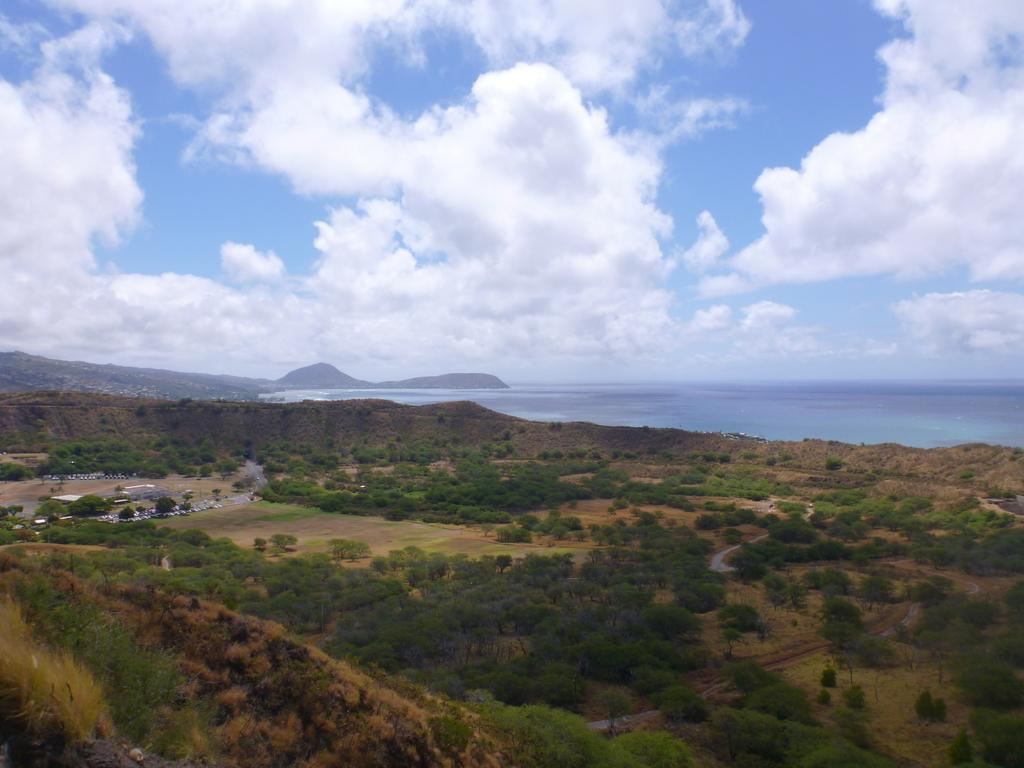What type of vegetation can be seen in the image? There are green color trees in the image. What natural feature is present near the trees? There is a sea in the image. What is the color of the sky in the image? The sky is blue in color. Are there any clouds visible in the sky? Yes, there are white color clouds in the sky. What type of pie is being served on the beach in the image? There is no pie present in the image; it features green trees, a sea, a blue sky, and white clouds. 